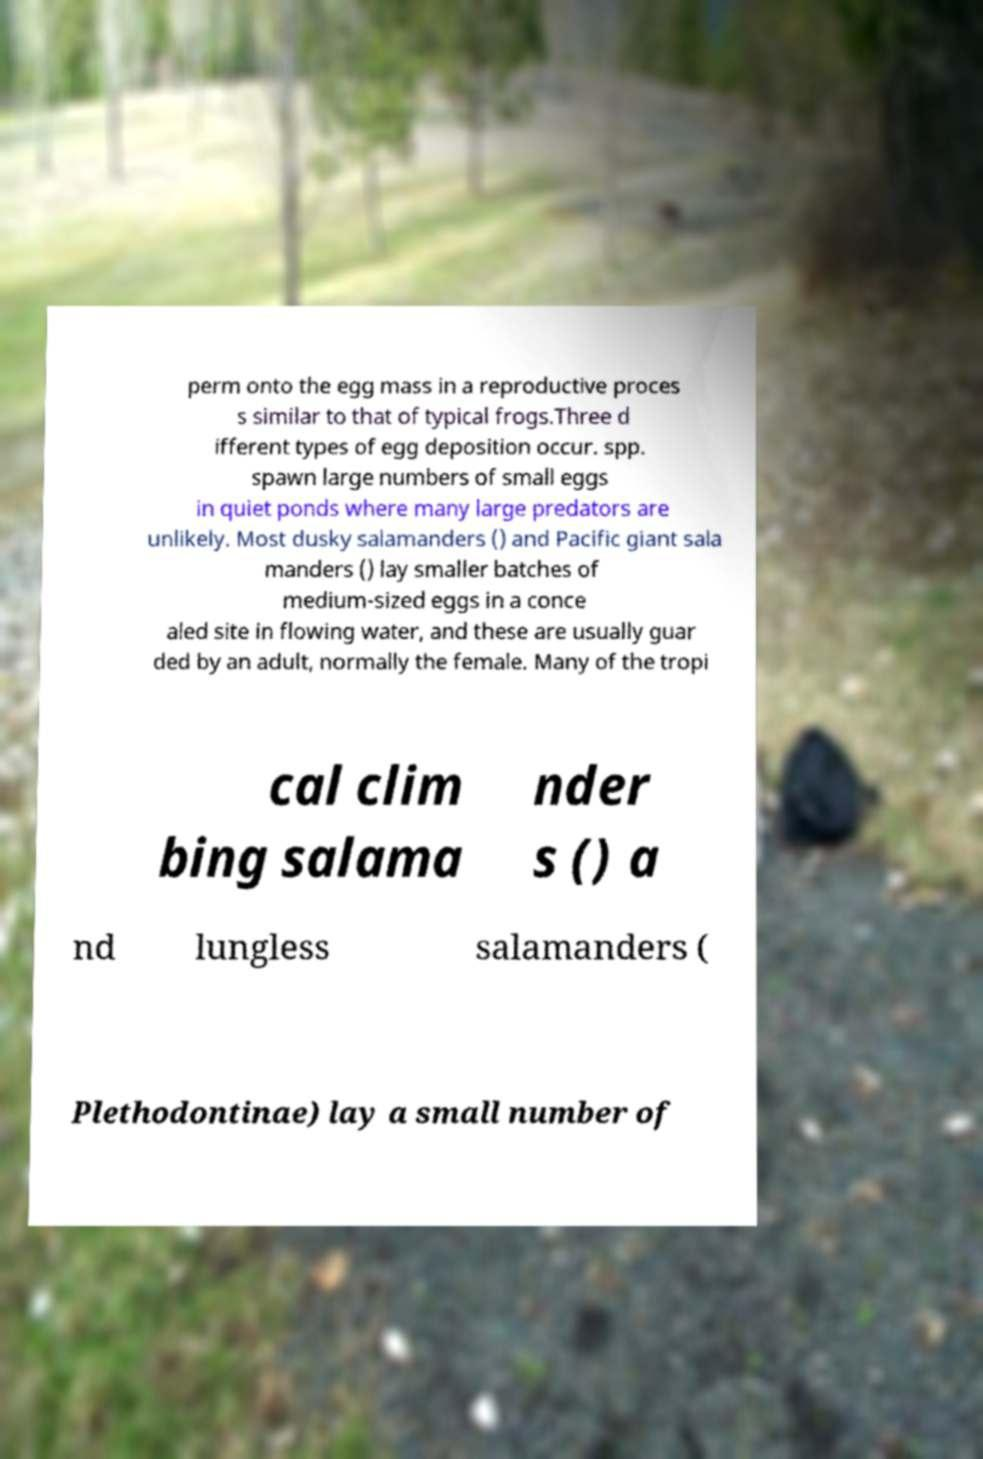Can you accurately transcribe the text from the provided image for me? perm onto the egg mass in a reproductive proces s similar to that of typical frogs.Three d ifferent types of egg deposition occur. spp. spawn large numbers of small eggs in quiet ponds where many large predators are unlikely. Most dusky salamanders () and Pacific giant sala manders () lay smaller batches of medium-sized eggs in a conce aled site in flowing water, and these are usually guar ded by an adult, normally the female. Many of the tropi cal clim bing salama nder s () a nd lungless salamanders ( Plethodontinae) lay a small number of 